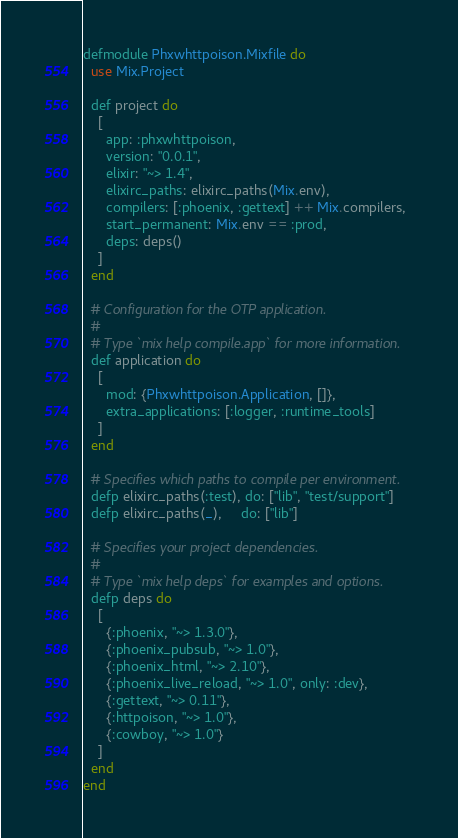Convert code to text. <code><loc_0><loc_0><loc_500><loc_500><_Elixir_>defmodule Phxwhttpoison.Mixfile do
  use Mix.Project

  def project do
    [
      app: :phxwhttpoison,
      version: "0.0.1",
      elixir: "~> 1.4",
      elixirc_paths: elixirc_paths(Mix.env),
      compilers: [:phoenix, :gettext] ++ Mix.compilers,
      start_permanent: Mix.env == :prod,
      deps: deps()
    ]
  end

  # Configuration for the OTP application.
  #
  # Type `mix help compile.app` for more information.
  def application do
    [
      mod: {Phxwhttpoison.Application, []},
      extra_applications: [:logger, :runtime_tools]
    ]
  end

  # Specifies which paths to compile per environment.
  defp elixirc_paths(:test), do: ["lib", "test/support"]
  defp elixirc_paths(_),     do: ["lib"]

  # Specifies your project dependencies.
  #
  # Type `mix help deps` for examples and options.
  defp deps do
    [
      {:phoenix, "~> 1.3.0"},
      {:phoenix_pubsub, "~> 1.0"},
      {:phoenix_html, "~> 2.10"},
      {:phoenix_live_reload, "~> 1.0", only: :dev},
      {:gettext, "~> 0.11"},
      {:httpoison, "~> 1.0"},
      {:cowboy, "~> 1.0"}
    ]
  end
end
</code> 